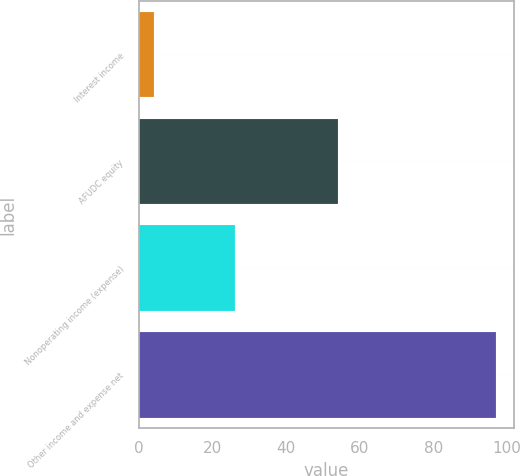Convert chart to OTSL. <chart><loc_0><loc_0><loc_500><loc_500><bar_chart><fcel>Interest income<fcel>AFUDC equity<fcel>Nonoperating income (expense)<fcel>Other income and expense net<nl><fcel>4<fcel>54<fcel>26<fcel>97<nl></chart> 